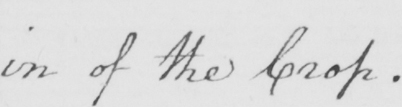Can you read and transcribe this handwriting? in of the crop . 